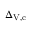<formula> <loc_0><loc_0><loc_500><loc_500>\Delta _ { V , c }</formula> 